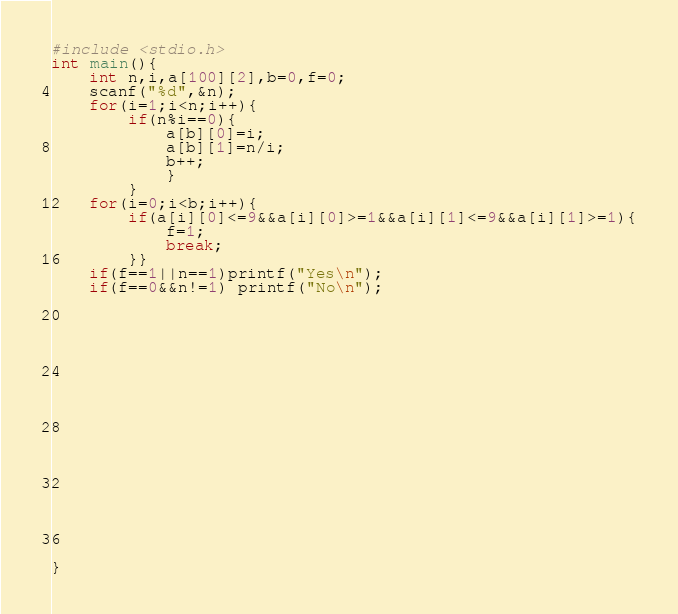<code> <loc_0><loc_0><loc_500><loc_500><_C_>#include <stdio.h>
int main(){
	int n,i,a[100][2],b=0,f=0;
	scanf("%d",&n);
	for(i=1;i<n;i++){
		if(n%i==0){
			a[b][0]=i;
			a[b][1]=n/i;
			b++;
			}
		}
	for(i=0;i<b;i++){
		if(a[i][0]<=9&&a[i][0]>=1&&a[i][1]<=9&&a[i][1]>=1){
			f=1;
			break;
		}}
	if(f==1||n==1)printf("Yes\n");
	if(f==0&&n!=1) printf("No\n");
	
	
	
	
	
	 
	
	
	
	
	
	
	
	
	
	
	
	
	
} 
</code> 